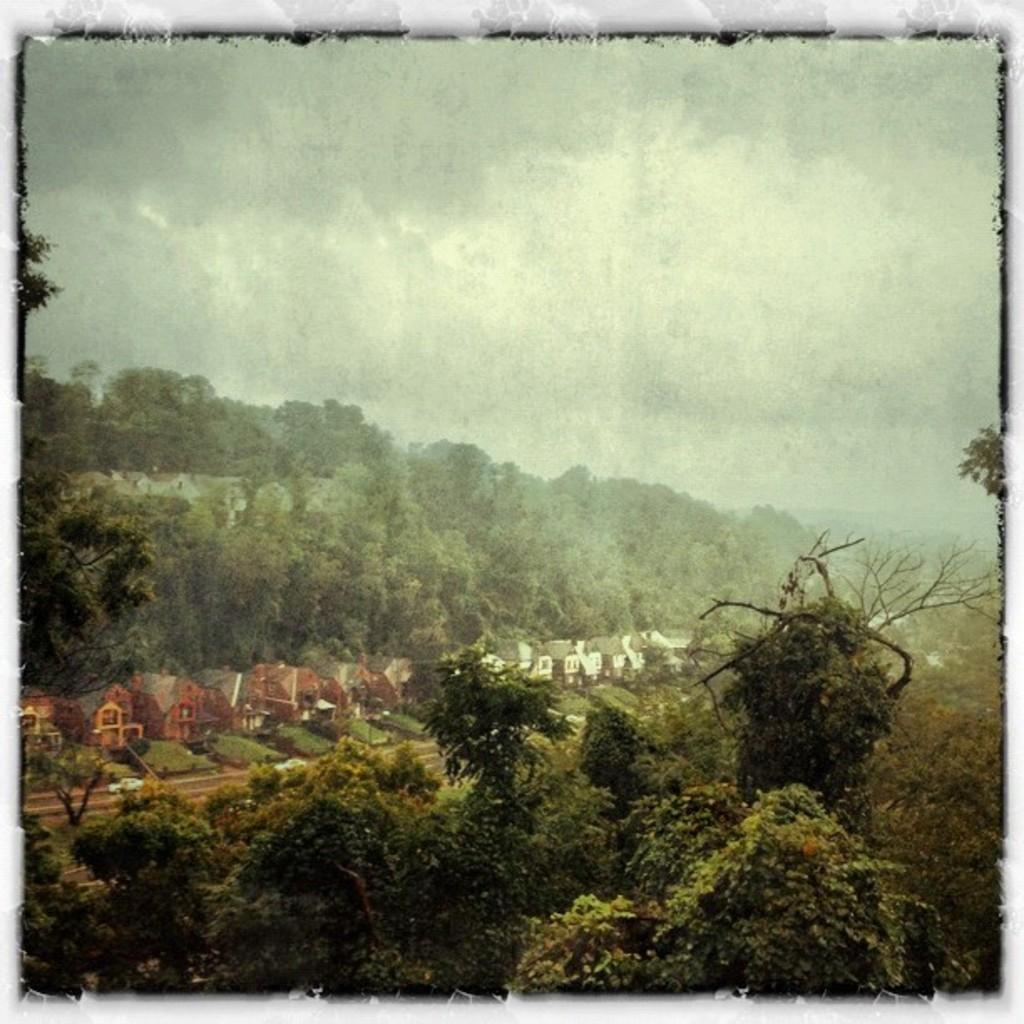What type of structures can be seen in the image? There are many houses in the image. What other natural elements are present in the image? There are trees in the image. How would you describe the weather based on the image? The sky is cloudy in the image. Are there any specific features of the image itself? The image has borders. What month is it in the image? The month cannot be determined from the image. 